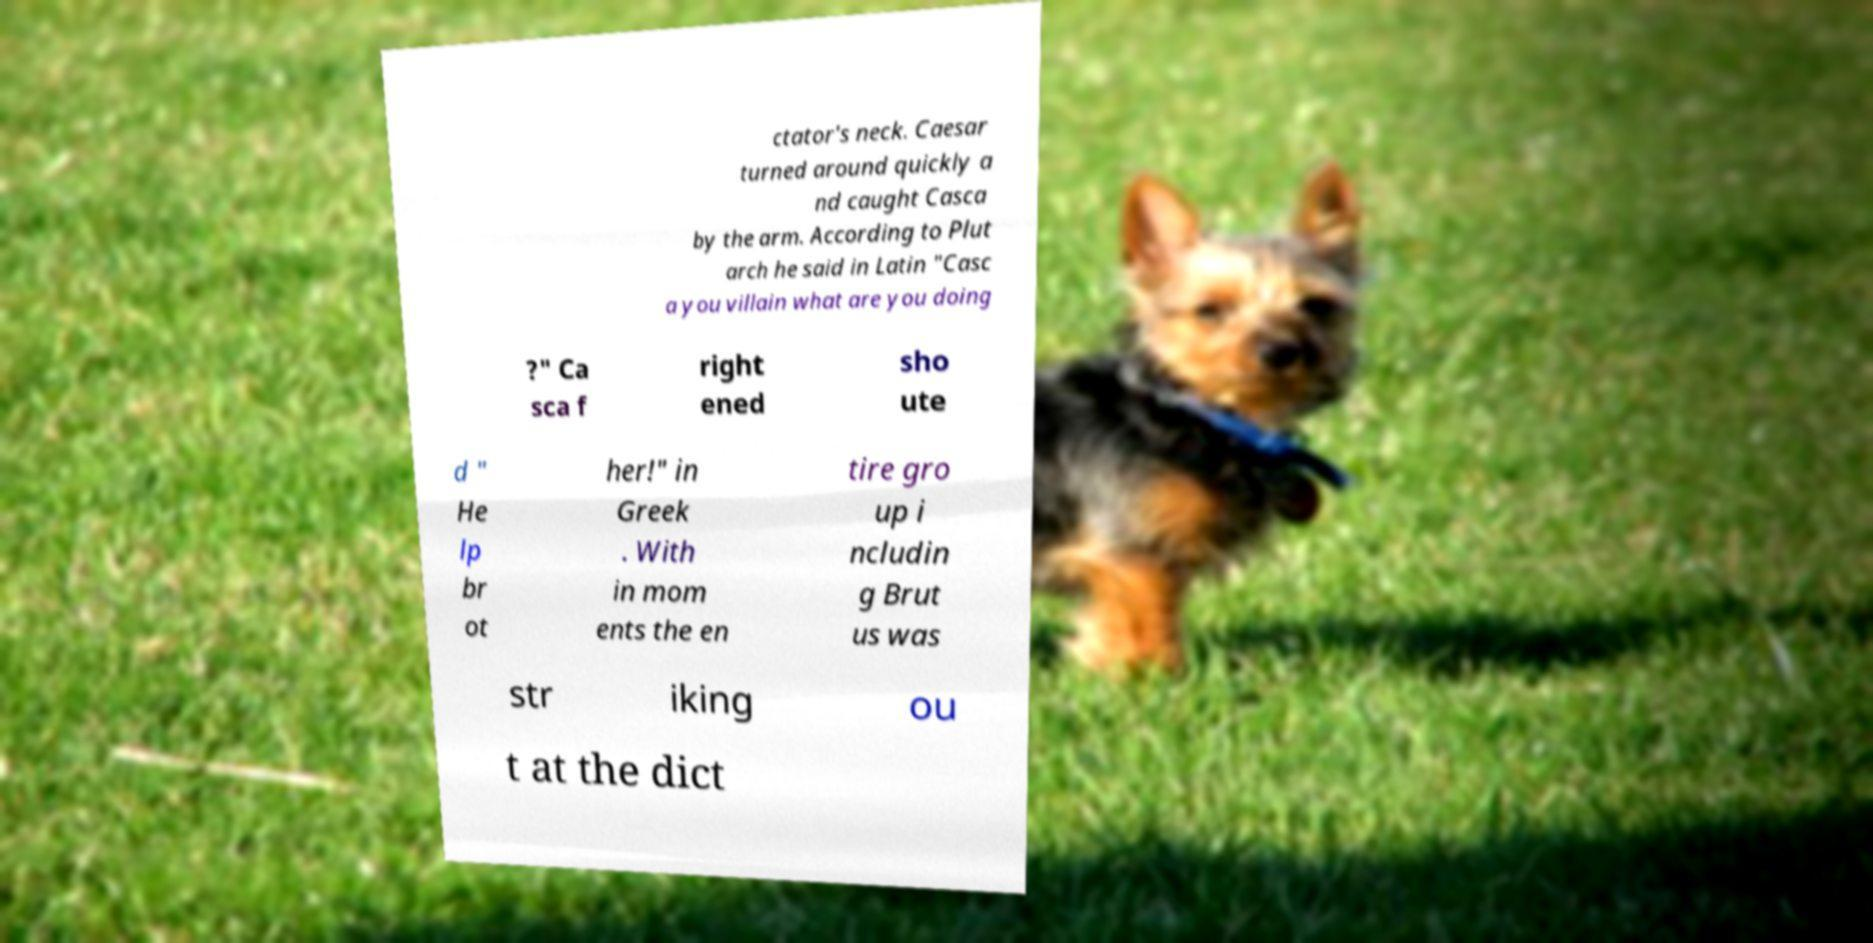For documentation purposes, I need the text within this image transcribed. Could you provide that? ctator's neck. Caesar turned around quickly a nd caught Casca by the arm. According to Plut arch he said in Latin "Casc a you villain what are you doing ?" Ca sca f right ened sho ute d " He lp br ot her!" in Greek . With in mom ents the en tire gro up i ncludin g Brut us was str iking ou t at the dict 